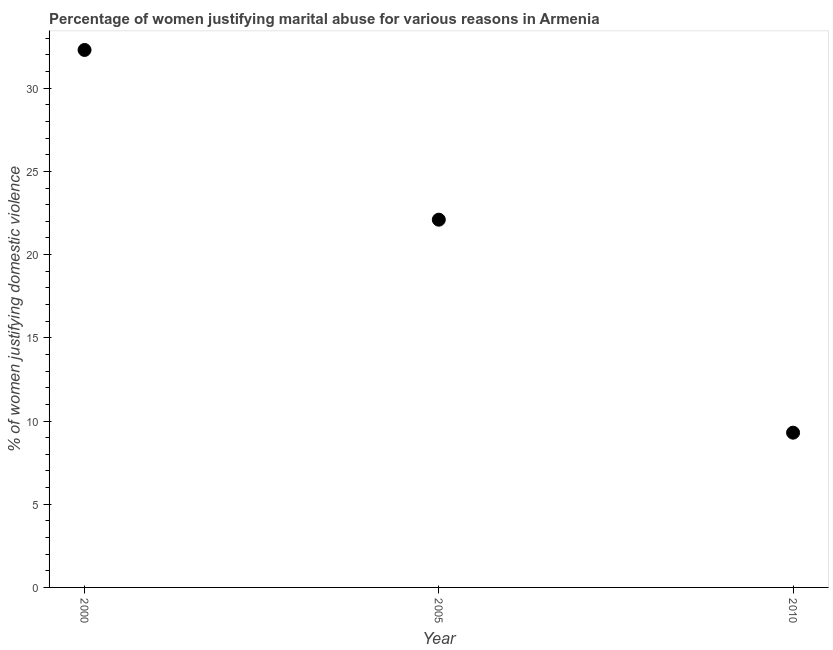What is the percentage of women justifying marital abuse in 2005?
Your answer should be compact. 22.1. Across all years, what is the maximum percentage of women justifying marital abuse?
Give a very brief answer. 32.3. What is the sum of the percentage of women justifying marital abuse?
Ensure brevity in your answer.  63.7. What is the difference between the percentage of women justifying marital abuse in 2000 and 2010?
Offer a terse response. 23. What is the average percentage of women justifying marital abuse per year?
Offer a very short reply. 21.23. What is the median percentage of women justifying marital abuse?
Provide a succinct answer. 22.1. What is the ratio of the percentage of women justifying marital abuse in 2000 to that in 2010?
Your response must be concise. 3.47. Is the difference between the percentage of women justifying marital abuse in 2000 and 2005 greater than the difference between any two years?
Your response must be concise. No. What is the difference between the highest and the second highest percentage of women justifying marital abuse?
Keep it short and to the point. 10.2. What is the difference between the highest and the lowest percentage of women justifying marital abuse?
Ensure brevity in your answer.  23. In how many years, is the percentage of women justifying marital abuse greater than the average percentage of women justifying marital abuse taken over all years?
Your answer should be compact. 2. Does the percentage of women justifying marital abuse monotonically increase over the years?
Your answer should be very brief. No. What is the difference between two consecutive major ticks on the Y-axis?
Keep it short and to the point. 5. Does the graph contain grids?
Make the answer very short. No. What is the title of the graph?
Offer a very short reply. Percentage of women justifying marital abuse for various reasons in Armenia. What is the label or title of the Y-axis?
Give a very brief answer. % of women justifying domestic violence. What is the % of women justifying domestic violence in 2000?
Make the answer very short. 32.3. What is the % of women justifying domestic violence in 2005?
Offer a very short reply. 22.1. What is the difference between the % of women justifying domestic violence in 2000 and 2010?
Provide a succinct answer. 23. What is the ratio of the % of women justifying domestic violence in 2000 to that in 2005?
Offer a very short reply. 1.46. What is the ratio of the % of women justifying domestic violence in 2000 to that in 2010?
Keep it short and to the point. 3.47. What is the ratio of the % of women justifying domestic violence in 2005 to that in 2010?
Keep it short and to the point. 2.38. 